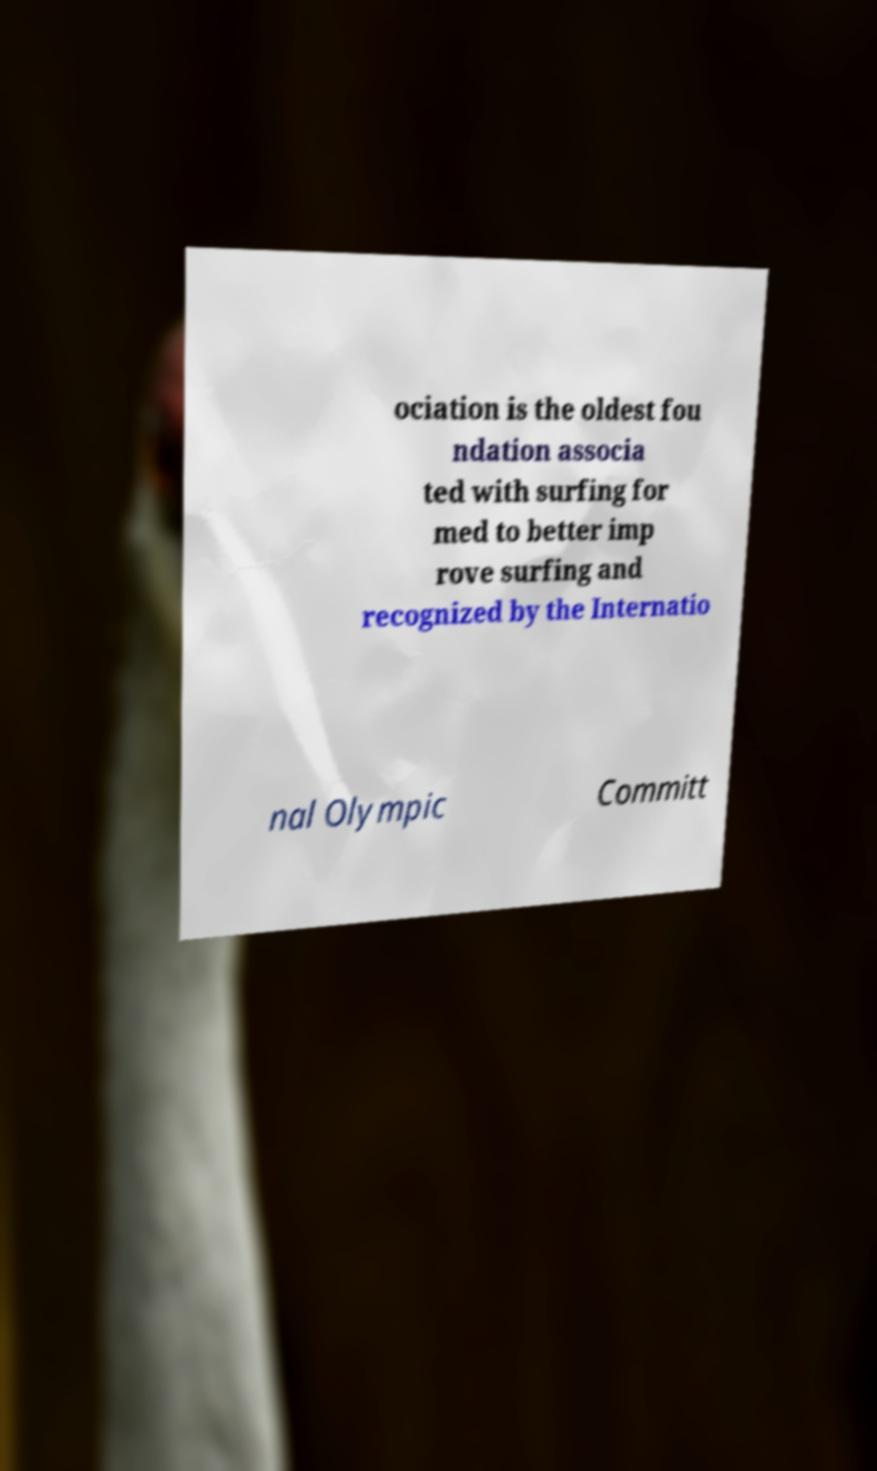Could you extract and type out the text from this image? ociation is the oldest fou ndation associa ted with surfing for med to better imp rove surfing and recognized by the Internatio nal Olympic Committ 